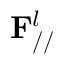<formula> <loc_0><loc_0><loc_500><loc_500>F _ { / / } ^ { l }</formula> 